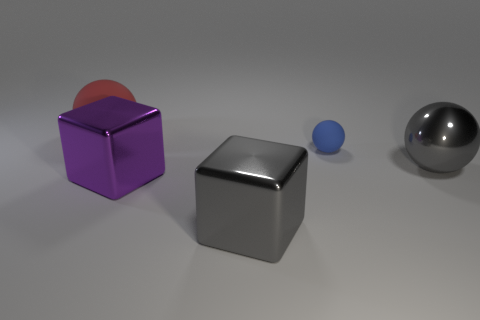Can you tell me what the materials of the objects appear to be? The objects in the image seem to have different finishes and tones suggesting various materials. The large gray object on the left looks metallic due to its shiny surface, while the purple object has a matte finish that implies a plastic-like material. The small ball looks rubbery based on its light diffusing surface, and the spherical object on the right also seems to have a metallic surface, reflecting light similarly to the big gray object. 